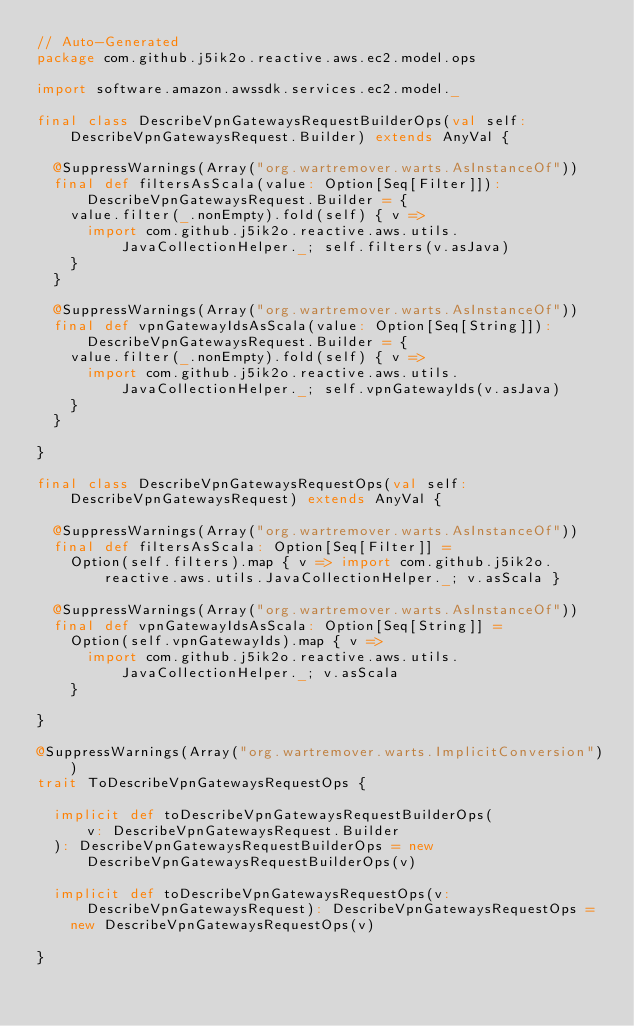Convert code to text. <code><loc_0><loc_0><loc_500><loc_500><_Scala_>// Auto-Generated
package com.github.j5ik2o.reactive.aws.ec2.model.ops

import software.amazon.awssdk.services.ec2.model._

final class DescribeVpnGatewaysRequestBuilderOps(val self: DescribeVpnGatewaysRequest.Builder) extends AnyVal {

  @SuppressWarnings(Array("org.wartremover.warts.AsInstanceOf"))
  final def filtersAsScala(value: Option[Seq[Filter]]): DescribeVpnGatewaysRequest.Builder = {
    value.filter(_.nonEmpty).fold(self) { v =>
      import com.github.j5ik2o.reactive.aws.utils.JavaCollectionHelper._; self.filters(v.asJava)
    }
  }

  @SuppressWarnings(Array("org.wartremover.warts.AsInstanceOf"))
  final def vpnGatewayIdsAsScala(value: Option[Seq[String]]): DescribeVpnGatewaysRequest.Builder = {
    value.filter(_.nonEmpty).fold(self) { v =>
      import com.github.j5ik2o.reactive.aws.utils.JavaCollectionHelper._; self.vpnGatewayIds(v.asJava)
    }
  }

}

final class DescribeVpnGatewaysRequestOps(val self: DescribeVpnGatewaysRequest) extends AnyVal {

  @SuppressWarnings(Array("org.wartremover.warts.AsInstanceOf"))
  final def filtersAsScala: Option[Seq[Filter]] =
    Option(self.filters).map { v => import com.github.j5ik2o.reactive.aws.utils.JavaCollectionHelper._; v.asScala }

  @SuppressWarnings(Array("org.wartremover.warts.AsInstanceOf"))
  final def vpnGatewayIdsAsScala: Option[Seq[String]] =
    Option(self.vpnGatewayIds).map { v =>
      import com.github.j5ik2o.reactive.aws.utils.JavaCollectionHelper._; v.asScala
    }

}

@SuppressWarnings(Array("org.wartremover.warts.ImplicitConversion"))
trait ToDescribeVpnGatewaysRequestOps {

  implicit def toDescribeVpnGatewaysRequestBuilderOps(
      v: DescribeVpnGatewaysRequest.Builder
  ): DescribeVpnGatewaysRequestBuilderOps = new DescribeVpnGatewaysRequestBuilderOps(v)

  implicit def toDescribeVpnGatewaysRequestOps(v: DescribeVpnGatewaysRequest): DescribeVpnGatewaysRequestOps =
    new DescribeVpnGatewaysRequestOps(v)

}
</code> 